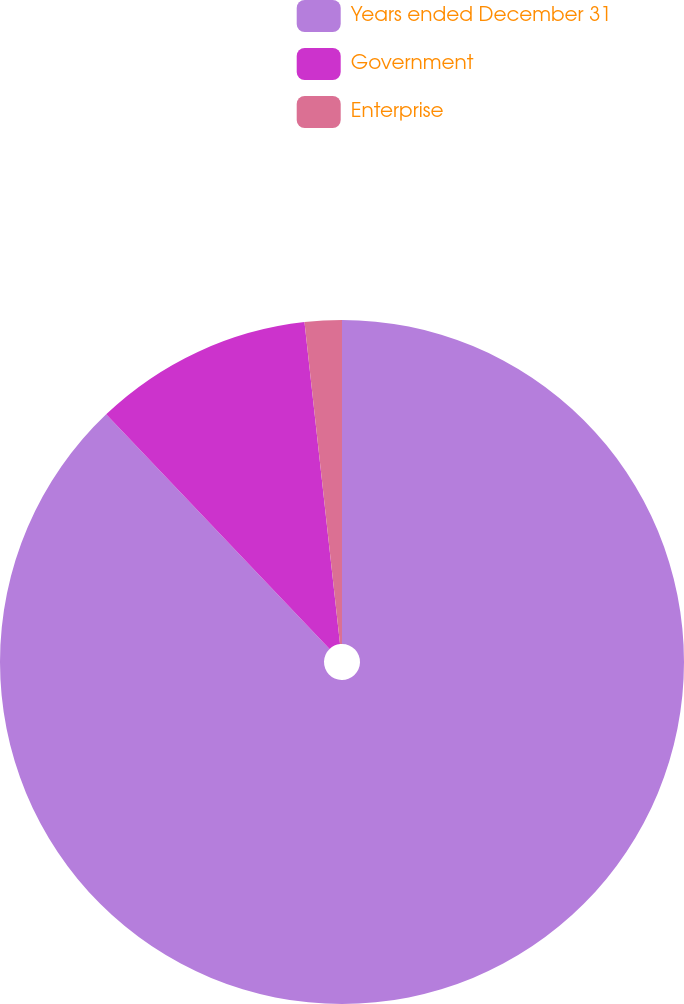Convert chart. <chart><loc_0><loc_0><loc_500><loc_500><pie_chart><fcel>Years ended December 31<fcel>Government<fcel>Enterprise<nl><fcel>87.89%<fcel>10.36%<fcel>1.75%<nl></chart> 